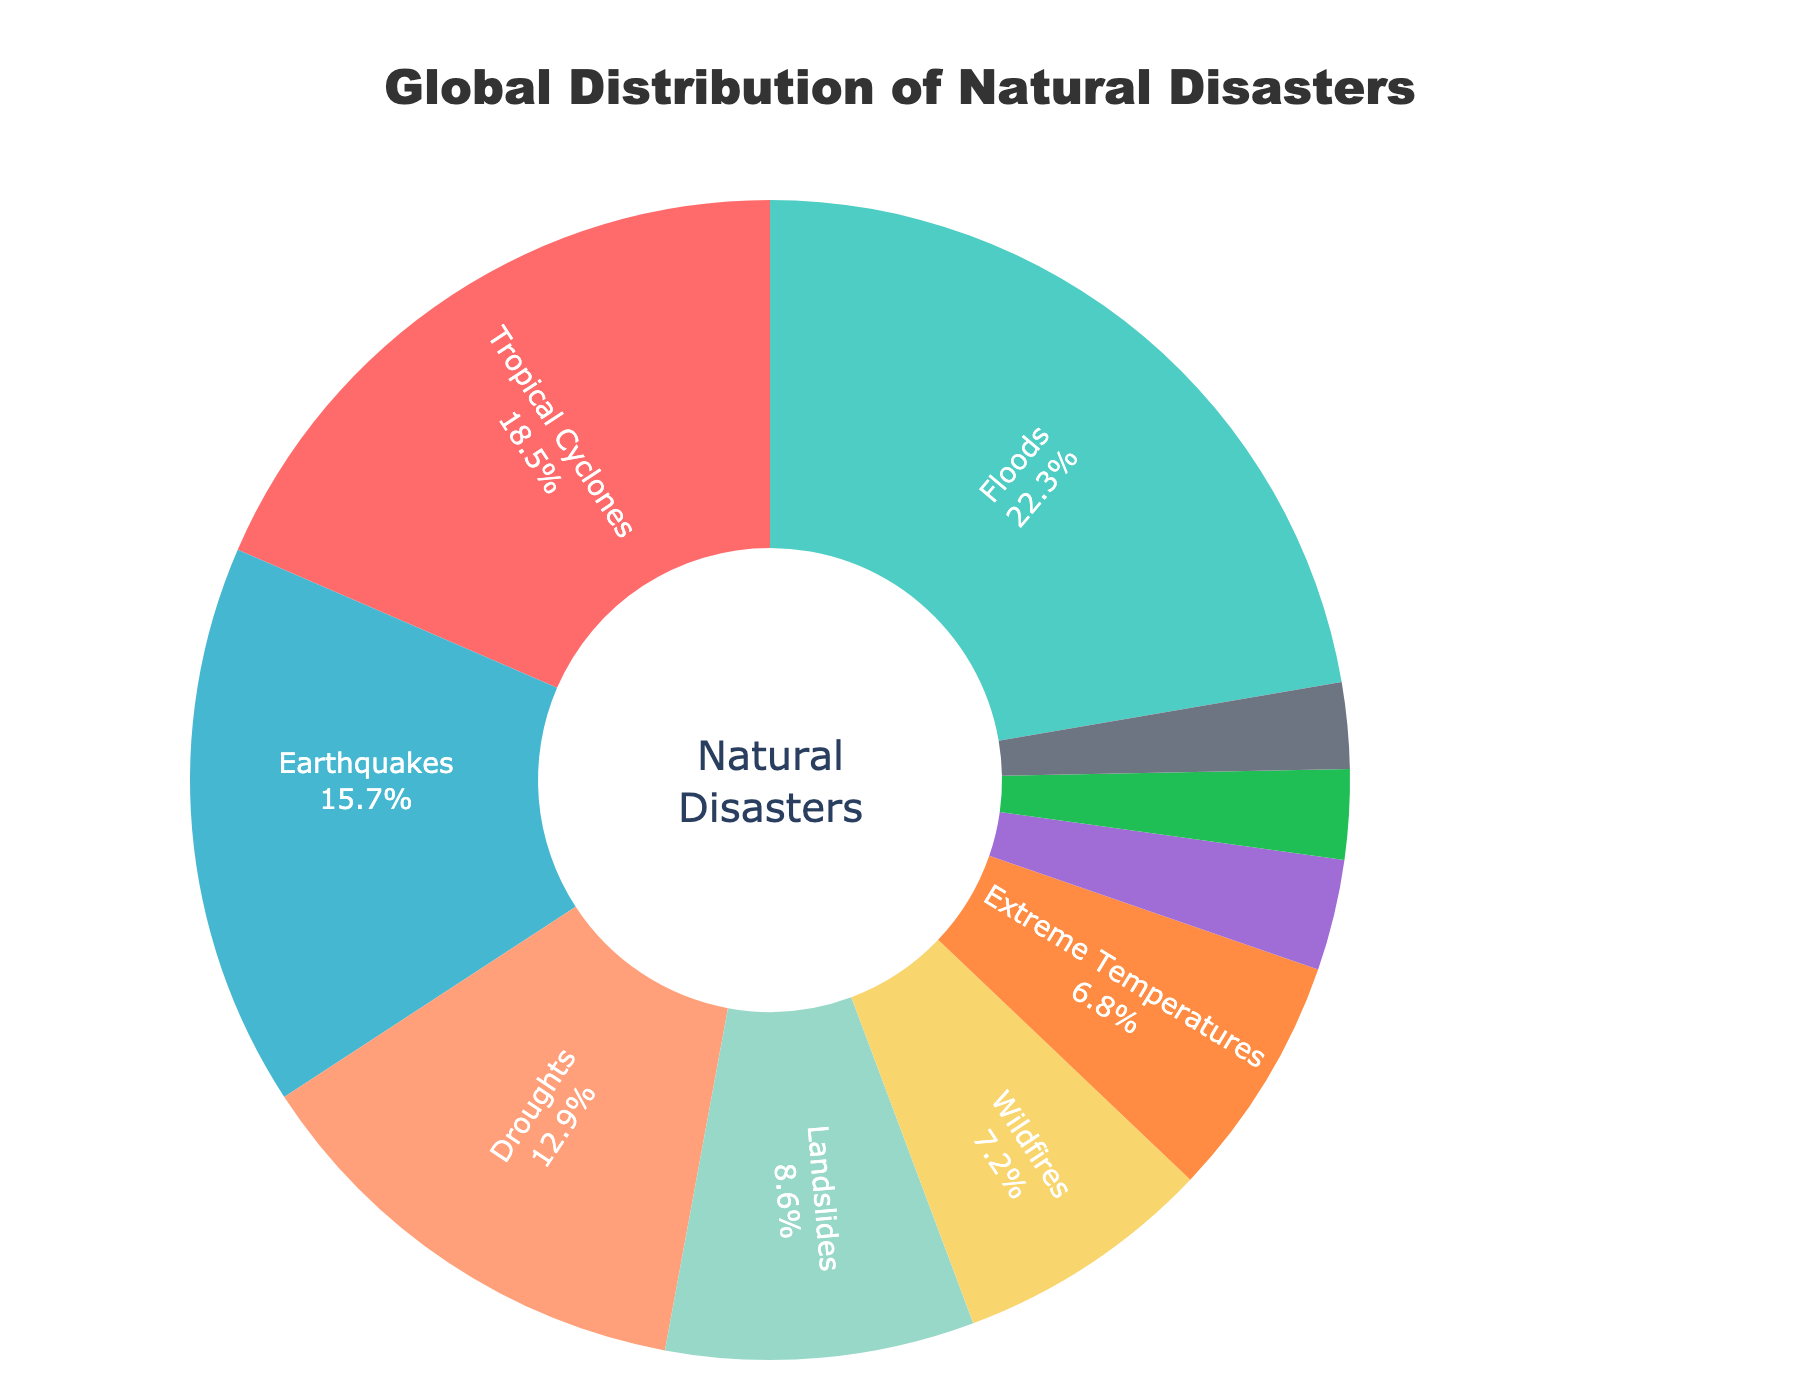What is the most common type of natural disaster? The largest segment of the pie chart represents Floods with 22.3%.
Answer: Floods Which natural disaster type has the smallest percentage? The smallest segment of the pie chart represents Tsunamis with 2.4%.
Answer: Tsunamis How much greater is the percentage of Tropical Cyclones compared to Extreme Temperatures? Tropical Cyclones have a percentage of 18.5%, and Extreme Temperatures have 6.8%. The difference is 18.5% - 6.8% = 11.7%.
Answer: 11.7% Which has a greater percentage, Earthquakes or Droughts? By how much? Earthquakes have a percentage of 15.7%, and Droughts have 12.9%. Earthquakes have a greater percentage by 15.7% - 12.9% = 2.8%.
Answer: Earthquakes by 2.8% What is the combined percentage of Landslides and Wildfires? Landslides make up 8.6%, and Wildfires make up 7.2%. The sum is 8.6% + 7.2% = 15.8%.
Answer: 15.8% How do the percentages of Volcanic Eruptions and Storm Surges compare? Volcanic Eruptions have 3.1%, and Storm Surges have 2.5%. Volcanic Eruptions have a higher percentage by 0.6%.
Answer: Volcanic Eruptions are higher by 0.6% Which disaster type occupies a visually larger segment, Droughts or Wildfires? The pie chart shows that Droughts, with 12.9%, occupy a larger segment than Wildfires, which have 7.2%.
Answer: Droughts If you combine the percentages of all disasters making up less than 5%, what is the total? The percentages of Volcanic Eruptions (3.1%) and Tsunamis (2.4%) add up to 3.1% + 2.4% = 5.5%.
Answer: 5.5% Rank the following disaster types by percentage from highest to lowest: Extreme Temperatures, Landslides, Wildfires. Extreme Temperatures have 6.8%, Landslides 8.6%, Wildfires 7.2%. The rank from highest to lowest is Landslides > Wildfires > Extreme Temperatures.
Answer: Landslides > Wildfires > Extreme Temperatures 